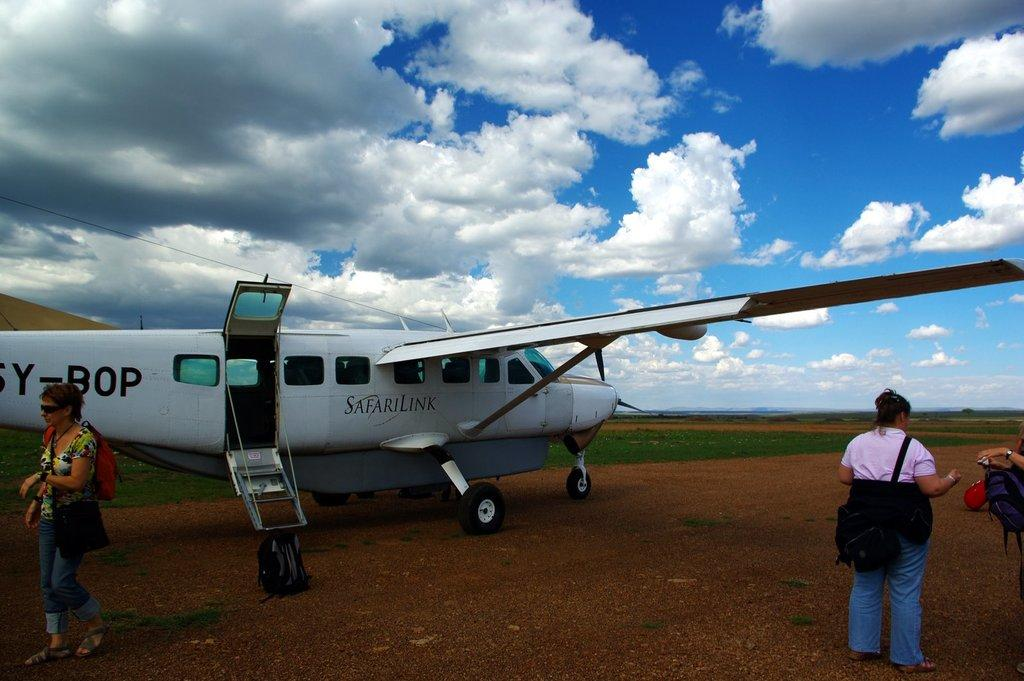What is the main subject of the image? The main subject of the image is an aircraft on the ground. Are there any people in the image? Yes, there are people visible in the image. What type of terrain is present in the image? Grass is present in the image. What can be seen in the background of the image? The sky is visible in the background of the image. How would you describe the weather based on the image? The sky appears to be cloudy in the image. What type of home can be seen in the image? There is no home present in the image; it features an aircraft on the ground. Are the people in the image swimming? There is no indication in the image that the people are swimming. 